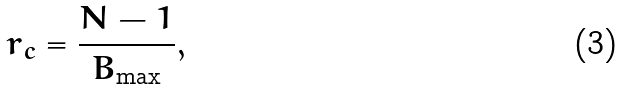<formula> <loc_0><loc_0><loc_500><loc_500>r _ { c } = \frac { N - 1 } { B _ { \max } } ,</formula> 